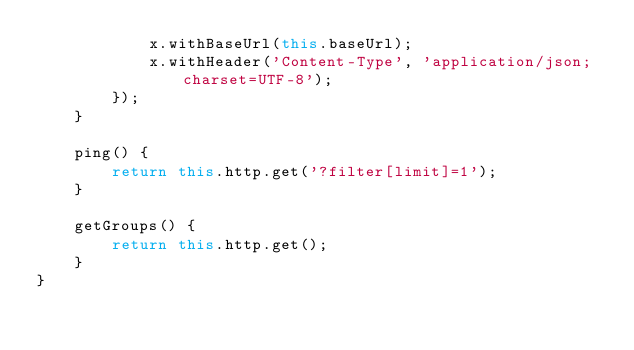Convert code to text. <code><loc_0><loc_0><loc_500><loc_500><_JavaScript_>            x.withBaseUrl(this.baseUrl);
            x.withHeader('Content-Type', 'application/json;charset=UTF-8');
        });
    }

    ping() {
		return this.http.get('?filter[limit]=1');
	}

    getGroups() {
        return this.http.get();
    }
}
</code> 